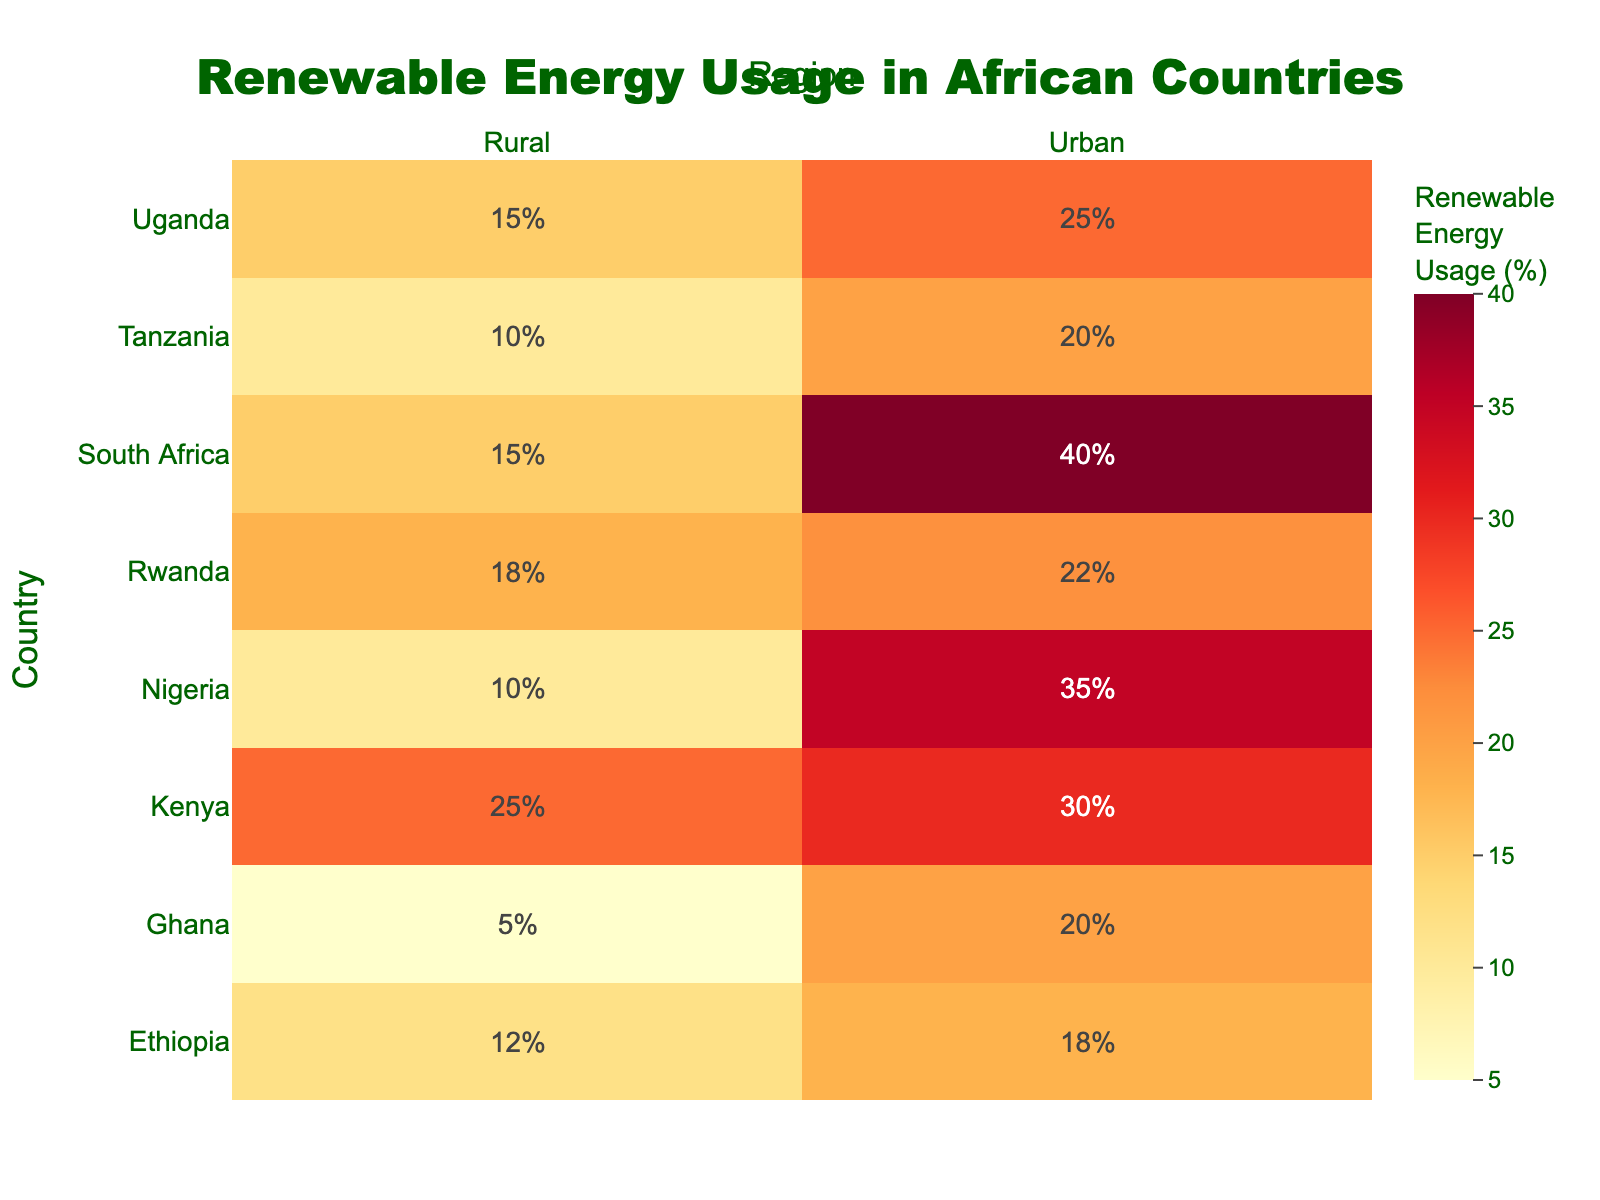What is the title of the heatmap? The title of the heatmap is clearly visible at the top center of the figure. It reads "Renewable Energy Usage in African Countries".
Answer: Renewable Energy Usage in African Countries Which region in Nigeria has a higher renewable energy usage percentage? By observing the heatmap, you can compare the values for the two regions in Nigeria. The urban region shows a higher percentage (35%) compared to the rural region (10%).
Answer: Urban How many countries are represented in the heatmap? Counting the distinct countries listed on the y-axis of the heatmap, we identify the following: Nigeria, South Africa, Kenya, Ghana, Uganda, Tanzania, Ethiopia, Rwanda. This sums up to eight countries.
Answer: 8 What is the renewable energy usage percentage in urban areas of South Africa? By locating South Africa on the y-axis and urban on the x-axis, we look at the intersecting cell which shows the value of 40%.
Answer: 40% Which country has the lowest renewable energy usage percentage in rural areas? By comparing the values listed under the rural column, the smallest value is 5% which is for Ghana.
Answer: Ghana What is the difference in renewable energy usage between urban and rural areas in Kenya? Identify the values for both urban (30%) and rural (25%) areas of Kenya, then calculate the difference: 30% - 25% = 5%.
Answer: 5% Which region (urban or rural) generally has a higher renewable energy usage percentage across all countries? Summarize and compare the percentages of renewable energy usage across all countries for both regions. It is evident that urban areas generally have higher percentages compared to rural areas.
Answer: Urban How much higher is the renewable energy usage in urban regions compared to rural regions in Uganda? The urban area in Uganda has a usage of 25%, and the rural area has 15%. The difference is calculated as 25% - 15% = 10%.
Answer: 10% Which countries have a renewable energy usage percentage greater than 20% in both urban and rural areas? Analyze the heatmap to find that Kenya and Rwanda are the countries with both urban and rural usage percentages above 20%.
Answer: Kenya, Rwanda What is the average renewable energy usage percentage in urban areas across all countries? Sum the urban percentages (35 + 40 + 30 + 20 + 25 + 20 + 18 + 22) = 210, then divide by the number of countries (8) to get the average: 210 / 8 = 26.25%.
Answer: 26.25% 